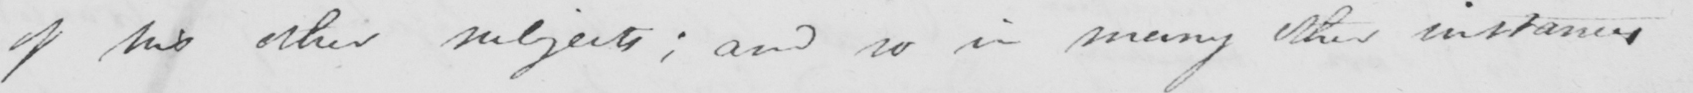What does this handwritten line say? of his other subjects ; and so in many other instances 